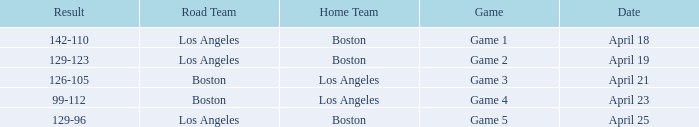WHAT IS THE RESULT OF THE GAME ON APRIL 23? 99-112. 